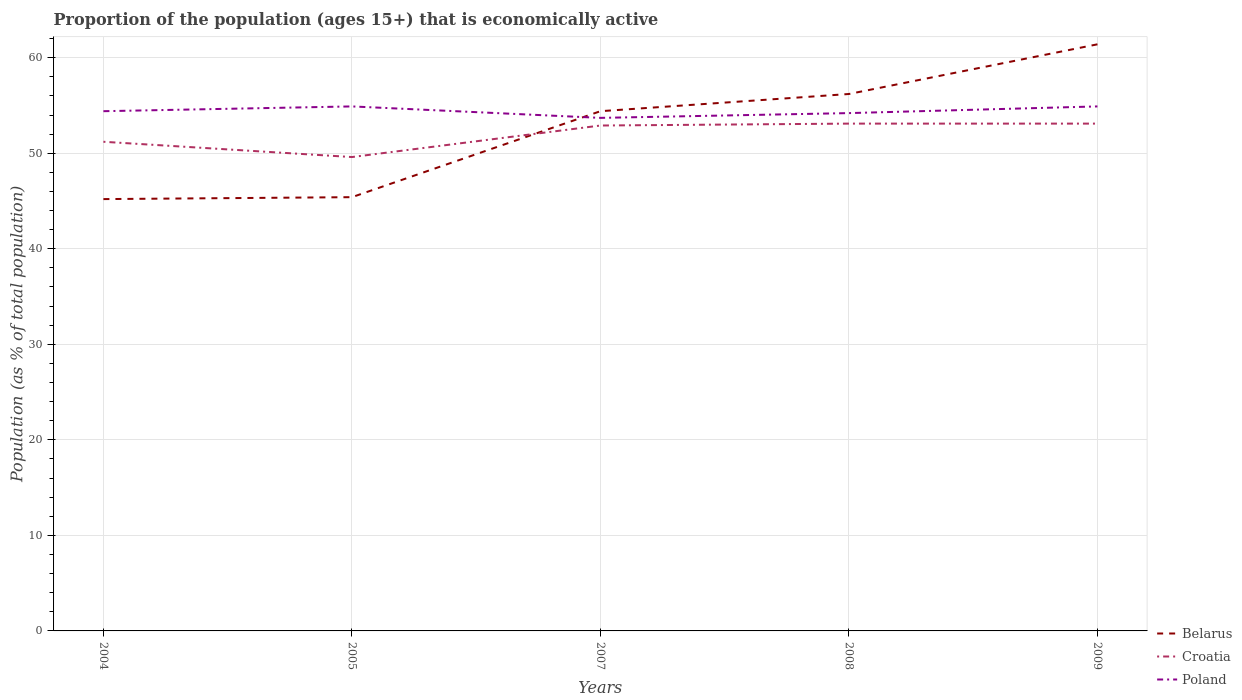How many different coloured lines are there?
Offer a very short reply. 3. Does the line corresponding to Croatia intersect with the line corresponding to Poland?
Ensure brevity in your answer.  No. Is the number of lines equal to the number of legend labels?
Offer a very short reply. Yes. Across all years, what is the maximum proportion of the population that is economically active in Croatia?
Your answer should be compact. 49.6. What is the total proportion of the population that is economically active in Croatia in the graph?
Give a very brief answer. -0.2. What is the difference between the highest and the second highest proportion of the population that is economically active in Poland?
Provide a short and direct response. 1.2. What is the difference between the highest and the lowest proportion of the population that is economically active in Croatia?
Keep it short and to the point. 3. Does the graph contain any zero values?
Ensure brevity in your answer.  No. Does the graph contain grids?
Provide a succinct answer. Yes. Where does the legend appear in the graph?
Offer a terse response. Bottom right. How many legend labels are there?
Provide a short and direct response. 3. What is the title of the graph?
Provide a succinct answer. Proportion of the population (ages 15+) that is economically active. What is the label or title of the Y-axis?
Offer a terse response. Population (as % of total population). What is the Population (as % of total population) of Belarus in 2004?
Keep it short and to the point. 45.2. What is the Population (as % of total population) of Croatia in 2004?
Provide a short and direct response. 51.2. What is the Population (as % of total population) of Poland in 2004?
Ensure brevity in your answer.  54.4. What is the Population (as % of total population) in Belarus in 2005?
Provide a short and direct response. 45.4. What is the Population (as % of total population) of Croatia in 2005?
Make the answer very short. 49.6. What is the Population (as % of total population) of Poland in 2005?
Provide a short and direct response. 54.9. What is the Population (as % of total population) of Belarus in 2007?
Provide a short and direct response. 54.4. What is the Population (as % of total population) of Croatia in 2007?
Ensure brevity in your answer.  52.9. What is the Population (as % of total population) in Poland in 2007?
Your response must be concise. 53.7. What is the Population (as % of total population) in Belarus in 2008?
Give a very brief answer. 56.2. What is the Population (as % of total population) of Croatia in 2008?
Your response must be concise. 53.1. What is the Population (as % of total population) of Poland in 2008?
Give a very brief answer. 54.2. What is the Population (as % of total population) of Belarus in 2009?
Your answer should be compact. 61.4. What is the Population (as % of total population) of Croatia in 2009?
Ensure brevity in your answer.  53.1. What is the Population (as % of total population) in Poland in 2009?
Make the answer very short. 54.9. Across all years, what is the maximum Population (as % of total population) in Belarus?
Your answer should be very brief. 61.4. Across all years, what is the maximum Population (as % of total population) of Croatia?
Give a very brief answer. 53.1. Across all years, what is the maximum Population (as % of total population) in Poland?
Make the answer very short. 54.9. Across all years, what is the minimum Population (as % of total population) in Belarus?
Ensure brevity in your answer.  45.2. Across all years, what is the minimum Population (as % of total population) of Croatia?
Provide a succinct answer. 49.6. Across all years, what is the minimum Population (as % of total population) in Poland?
Make the answer very short. 53.7. What is the total Population (as % of total population) in Belarus in the graph?
Your answer should be very brief. 262.6. What is the total Population (as % of total population) of Croatia in the graph?
Your response must be concise. 259.9. What is the total Population (as % of total population) of Poland in the graph?
Your response must be concise. 272.1. What is the difference between the Population (as % of total population) in Belarus in 2004 and that in 2005?
Give a very brief answer. -0.2. What is the difference between the Population (as % of total population) in Poland in 2004 and that in 2005?
Offer a terse response. -0.5. What is the difference between the Population (as % of total population) of Belarus in 2004 and that in 2007?
Your response must be concise. -9.2. What is the difference between the Population (as % of total population) of Croatia in 2004 and that in 2007?
Make the answer very short. -1.7. What is the difference between the Population (as % of total population) of Belarus in 2004 and that in 2009?
Keep it short and to the point. -16.2. What is the difference between the Population (as % of total population) in Croatia in 2004 and that in 2009?
Provide a succinct answer. -1.9. What is the difference between the Population (as % of total population) in Poland in 2004 and that in 2009?
Your response must be concise. -0.5. What is the difference between the Population (as % of total population) in Belarus in 2005 and that in 2007?
Give a very brief answer. -9. What is the difference between the Population (as % of total population) in Croatia in 2005 and that in 2007?
Provide a short and direct response. -3.3. What is the difference between the Population (as % of total population) in Croatia in 2005 and that in 2009?
Give a very brief answer. -3.5. What is the difference between the Population (as % of total population) of Croatia in 2007 and that in 2008?
Ensure brevity in your answer.  -0.2. What is the difference between the Population (as % of total population) of Poland in 2007 and that in 2008?
Make the answer very short. -0.5. What is the difference between the Population (as % of total population) of Belarus in 2007 and that in 2009?
Your answer should be compact. -7. What is the difference between the Population (as % of total population) of Croatia in 2007 and that in 2009?
Offer a very short reply. -0.2. What is the difference between the Population (as % of total population) of Belarus in 2008 and that in 2009?
Your answer should be very brief. -5.2. What is the difference between the Population (as % of total population) of Croatia in 2008 and that in 2009?
Ensure brevity in your answer.  0. What is the difference between the Population (as % of total population) of Belarus in 2004 and the Population (as % of total population) of Poland in 2005?
Your answer should be very brief. -9.7. What is the difference between the Population (as % of total population) in Croatia in 2004 and the Population (as % of total population) in Poland in 2005?
Make the answer very short. -3.7. What is the difference between the Population (as % of total population) in Croatia in 2004 and the Population (as % of total population) in Poland in 2008?
Your answer should be very brief. -3. What is the difference between the Population (as % of total population) of Belarus in 2004 and the Population (as % of total population) of Poland in 2009?
Provide a short and direct response. -9.7. What is the difference between the Population (as % of total population) in Croatia in 2004 and the Population (as % of total population) in Poland in 2009?
Give a very brief answer. -3.7. What is the difference between the Population (as % of total population) in Belarus in 2005 and the Population (as % of total population) in Croatia in 2007?
Provide a succinct answer. -7.5. What is the difference between the Population (as % of total population) of Croatia in 2005 and the Population (as % of total population) of Poland in 2007?
Provide a short and direct response. -4.1. What is the difference between the Population (as % of total population) of Croatia in 2005 and the Population (as % of total population) of Poland in 2009?
Your answer should be very brief. -5.3. What is the difference between the Population (as % of total population) of Belarus in 2007 and the Population (as % of total population) of Croatia in 2008?
Your response must be concise. 1.3. What is the difference between the Population (as % of total population) of Belarus in 2007 and the Population (as % of total population) of Croatia in 2009?
Your answer should be very brief. 1.3. What is the difference between the Population (as % of total population) in Belarus in 2007 and the Population (as % of total population) in Poland in 2009?
Give a very brief answer. -0.5. What is the difference between the Population (as % of total population) in Belarus in 2008 and the Population (as % of total population) in Croatia in 2009?
Your response must be concise. 3.1. What is the difference between the Population (as % of total population) in Croatia in 2008 and the Population (as % of total population) in Poland in 2009?
Provide a short and direct response. -1.8. What is the average Population (as % of total population) in Belarus per year?
Provide a short and direct response. 52.52. What is the average Population (as % of total population) in Croatia per year?
Provide a succinct answer. 51.98. What is the average Population (as % of total population) of Poland per year?
Ensure brevity in your answer.  54.42. In the year 2004, what is the difference between the Population (as % of total population) in Croatia and Population (as % of total population) in Poland?
Offer a terse response. -3.2. In the year 2005, what is the difference between the Population (as % of total population) in Belarus and Population (as % of total population) in Croatia?
Your answer should be very brief. -4.2. In the year 2005, what is the difference between the Population (as % of total population) in Belarus and Population (as % of total population) in Poland?
Offer a terse response. -9.5. In the year 2005, what is the difference between the Population (as % of total population) of Croatia and Population (as % of total population) of Poland?
Keep it short and to the point. -5.3. In the year 2007, what is the difference between the Population (as % of total population) of Belarus and Population (as % of total population) of Poland?
Make the answer very short. 0.7. In the year 2008, what is the difference between the Population (as % of total population) of Belarus and Population (as % of total population) of Croatia?
Offer a very short reply. 3.1. In the year 2008, what is the difference between the Population (as % of total population) in Croatia and Population (as % of total population) in Poland?
Keep it short and to the point. -1.1. In the year 2009, what is the difference between the Population (as % of total population) of Belarus and Population (as % of total population) of Poland?
Offer a terse response. 6.5. What is the ratio of the Population (as % of total population) in Belarus in 2004 to that in 2005?
Offer a terse response. 1. What is the ratio of the Population (as % of total population) in Croatia in 2004 to that in 2005?
Provide a succinct answer. 1.03. What is the ratio of the Population (as % of total population) in Poland in 2004 to that in 2005?
Your answer should be compact. 0.99. What is the ratio of the Population (as % of total population) in Belarus in 2004 to that in 2007?
Provide a short and direct response. 0.83. What is the ratio of the Population (as % of total population) of Croatia in 2004 to that in 2007?
Give a very brief answer. 0.97. What is the ratio of the Population (as % of total population) of Belarus in 2004 to that in 2008?
Your answer should be very brief. 0.8. What is the ratio of the Population (as % of total population) of Croatia in 2004 to that in 2008?
Give a very brief answer. 0.96. What is the ratio of the Population (as % of total population) in Poland in 2004 to that in 2008?
Make the answer very short. 1. What is the ratio of the Population (as % of total population) in Belarus in 2004 to that in 2009?
Your answer should be very brief. 0.74. What is the ratio of the Population (as % of total population) in Croatia in 2004 to that in 2009?
Offer a very short reply. 0.96. What is the ratio of the Population (as % of total population) of Poland in 2004 to that in 2009?
Provide a succinct answer. 0.99. What is the ratio of the Population (as % of total population) in Belarus in 2005 to that in 2007?
Give a very brief answer. 0.83. What is the ratio of the Population (as % of total population) in Croatia in 2005 to that in 2007?
Offer a terse response. 0.94. What is the ratio of the Population (as % of total population) in Poland in 2005 to that in 2007?
Provide a short and direct response. 1.02. What is the ratio of the Population (as % of total population) in Belarus in 2005 to that in 2008?
Your response must be concise. 0.81. What is the ratio of the Population (as % of total population) of Croatia in 2005 to that in 2008?
Provide a succinct answer. 0.93. What is the ratio of the Population (as % of total population) of Poland in 2005 to that in 2008?
Provide a short and direct response. 1.01. What is the ratio of the Population (as % of total population) in Belarus in 2005 to that in 2009?
Your response must be concise. 0.74. What is the ratio of the Population (as % of total population) of Croatia in 2005 to that in 2009?
Provide a succinct answer. 0.93. What is the ratio of the Population (as % of total population) in Poland in 2005 to that in 2009?
Your response must be concise. 1. What is the ratio of the Population (as % of total population) in Belarus in 2007 to that in 2008?
Provide a succinct answer. 0.97. What is the ratio of the Population (as % of total population) of Poland in 2007 to that in 2008?
Ensure brevity in your answer.  0.99. What is the ratio of the Population (as % of total population) of Belarus in 2007 to that in 2009?
Give a very brief answer. 0.89. What is the ratio of the Population (as % of total population) in Poland in 2007 to that in 2009?
Provide a short and direct response. 0.98. What is the ratio of the Population (as % of total population) in Belarus in 2008 to that in 2009?
Offer a very short reply. 0.92. What is the ratio of the Population (as % of total population) of Poland in 2008 to that in 2009?
Give a very brief answer. 0.99. What is the difference between the highest and the second highest Population (as % of total population) in Belarus?
Your answer should be very brief. 5.2. What is the difference between the highest and the second highest Population (as % of total population) of Poland?
Provide a succinct answer. 0. What is the difference between the highest and the lowest Population (as % of total population) of Belarus?
Offer a terse response. 16.2. What is the difference between the highest and the lowest Population (as % of total population) of Croatia?
Keep it short and to the point. 3.5. 